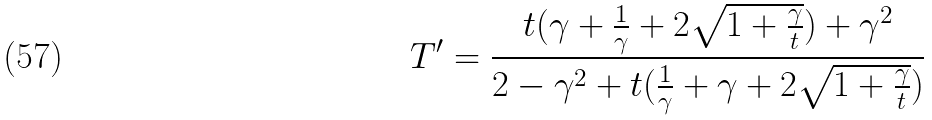<formula> <loc_0><loc_0><loc_500><loc_500>T ^ { \prime } = \frac { t ( \gamma + \frac { 1 } { \gamma } + 2 \sqrt { 1 + \frac { \gamma } { t } } ) + \gamma ^ { 2 } } { 2 - \gamma ^ { 2 } + t ( \frac { 1 } { \gamma } + \gamma + 2 \sqrt { 1 + \frac { \gamma } { t } } ) }</formula> 